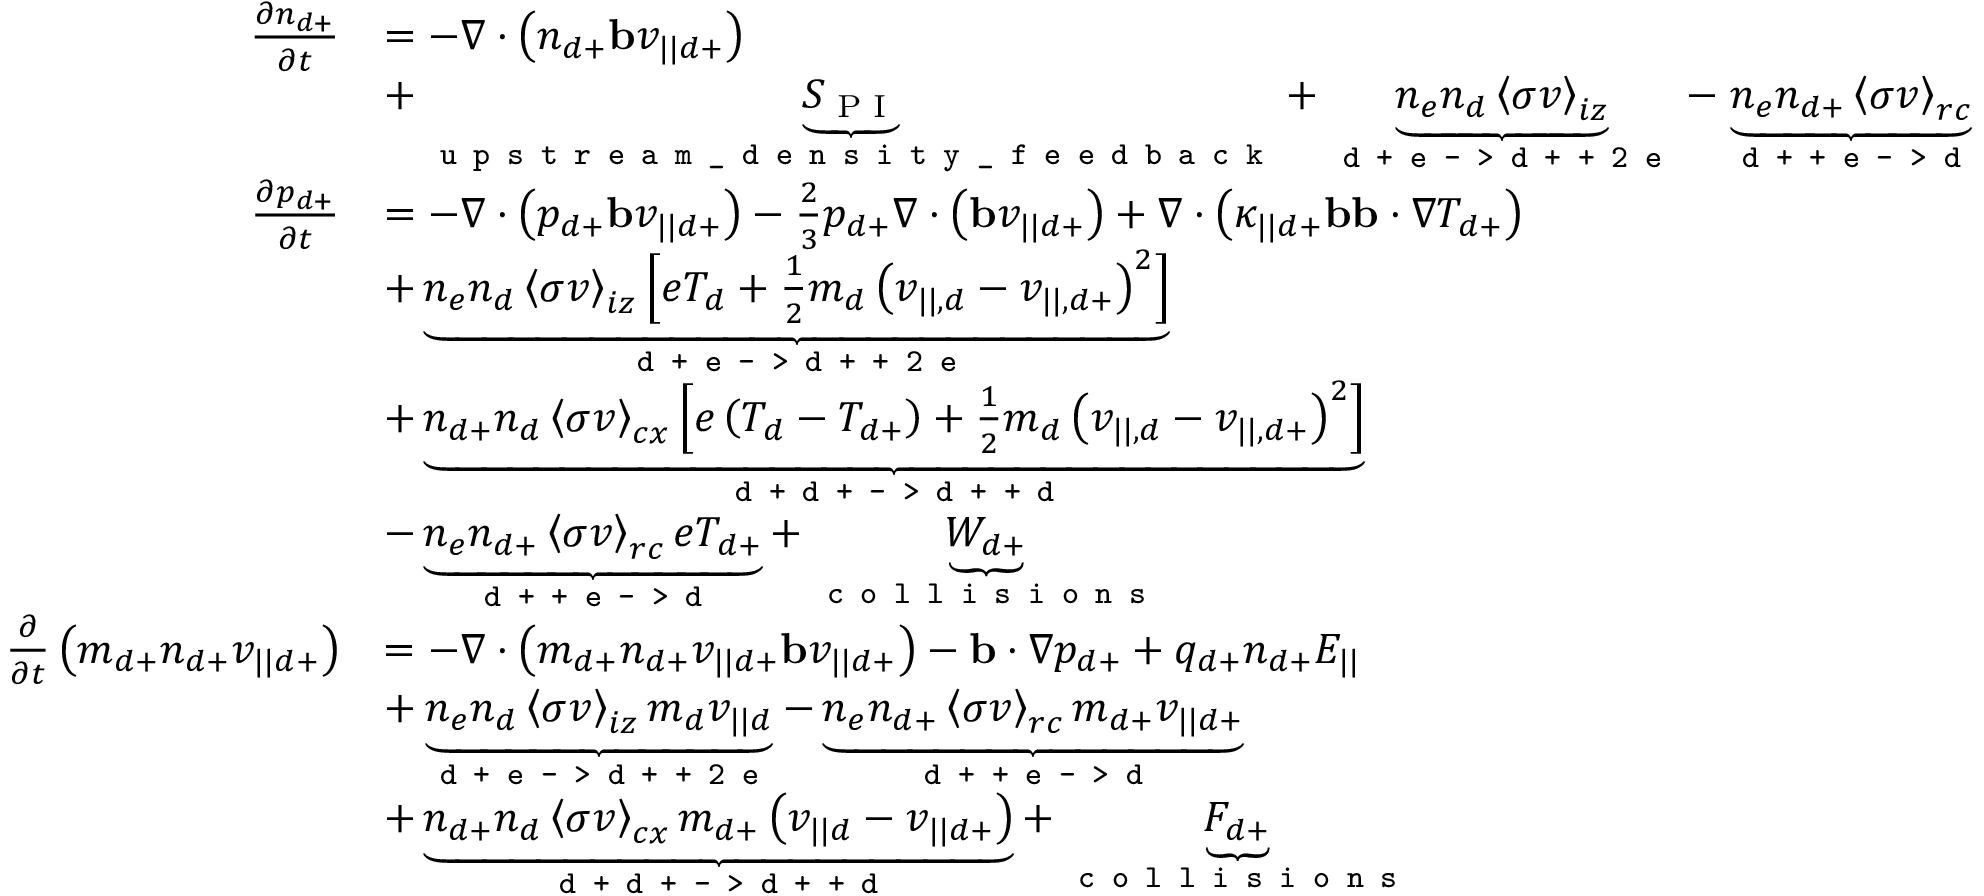<formula> <loc_0><loc_0><loc_500><loc_500>\begin{array} { r l } { \frac { \partial n _ { d + } } { \partial t } } & { = - \nabla \cdot \left ( n _ { d + } b v _ { | | d + } \right ) } \\ & { + \underbrace { S _ { P I } } _ { u p s t r e a m \_ d e n s i t y \_ f e e d b a c k } + \underbrace { n _ { e } n _ { d } \left < \sigma v \right > _ { i z } } _ { d + e - > d + + 2 e } - \underbrace { n _ { e } n _ { d + } \left < \sigma v \right > _ { r c } } _ { d + + e - > d } } \\ { \frac { \partial p _ { d + } } { \partial t } } & { = - \nabla \cdot \left ( p _ { d + } b v _ { | | d + } \right ) - \frac { 2 } { 3 } p _ { d + } \nabla \cdot \left ( b v _ { | | d + } \right ) + \nabla \cdot \left ( \kappa _ { | | d + } b b \cdot \nabla T _ { d + } \right ) } \\ & { + \underbrace { n _ { e } n _ { d } \left < \sigma v \right > _ { i z } \left [ e T _ { d } + \frac { 1 } { 2 } m _ { d } \left ( v _ { | | , d } - v _ { | | , d + } \right ) ^ { 2 } \right ] } _ { d + e - > d + + 2 e } } \\ & { + \underbrace { n _ { d + } n _ { d } \left < \sigma v \right > _ { c x } \left [ e \left ( T _ { d } - T _ { d + } \right ) + \frac { 1 } { 2 } m _ { d } \left ( v _ { | | , d } - v _ { | | , d + } \right ) ^ { 2 } \right ] } _ { d + d + - > d + + d } } \\ & { - \underbrace { n _ { e } n _ { d + } \left < \sigma v \right > _ { r c } e T _ { d + } } _ { d + + e - > d } + \underbrace { W _ { d + } } _ { c o l l i s i o n s } } \\ { \frac { \partial } { \partial t } \left ( m _ { d + } n _ { d + } v _ { | | d + } \right ) } & { = - \nabla \cdot \left ( m _ { d + } n _ { d + } v _ { | | d + } b v _ { | | d + } \right ) - b \cdot \nabla p _ { d + } + q _ { d + } n _ { d + } E _ { | | } } \\ & { + \underbrace { n _ { e } n _ { d } \left < \sigma v \right > _ { i z } m _ { d } v _ { | | d } } _ { d + e - > d + + 2 e } - \underbrace { n _ { e } n _ { d + } \left < \sigma v \right > _ { r c } m _ { d + } v _ { | | d + } } _ { d + + e - > d } } \\ & { + \underbrace { n _ { d + } n _ { d } \left < \sigma v \right > _ { c x } m _ { d + } \left ( v _ { | | d } - v _ { | | d + } \right ) } _ { d + d + - > d + + d } + \underbrace { F _ { d + } } _ { c o l l i s i o n s } } \end{array}</formula> 